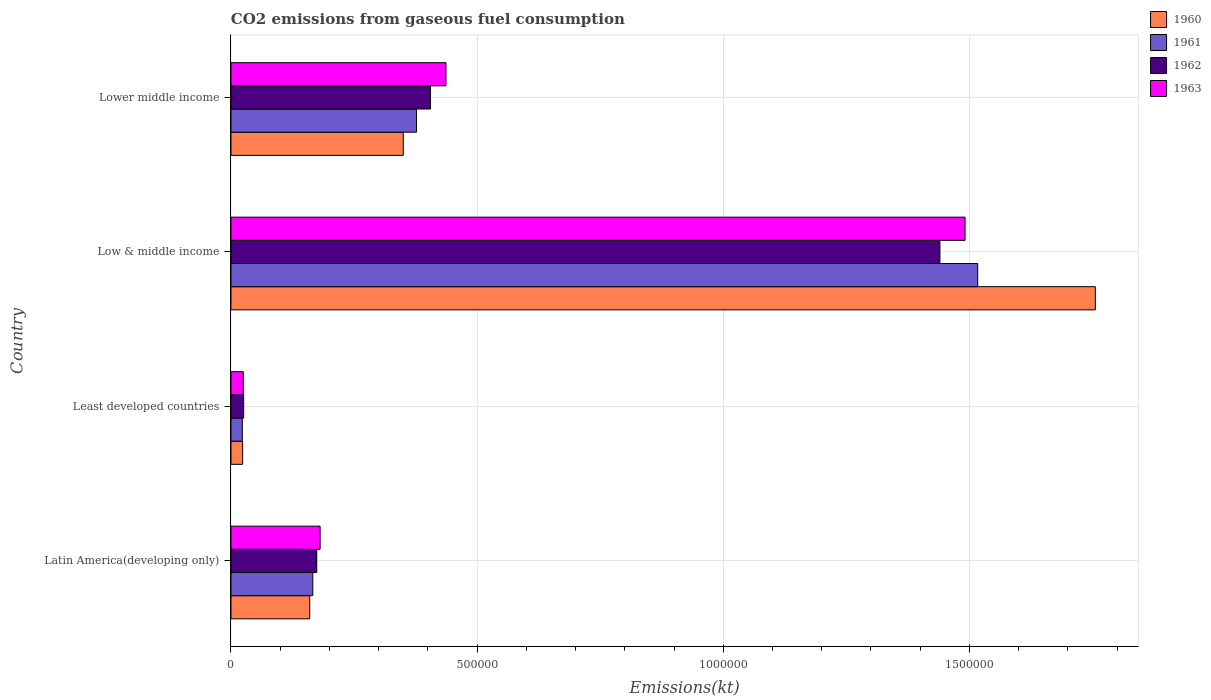Are the number of bars per tick equal to the number of legend labels?
Your answer should be very brief. Yes. How many bars are there on the 3rd tick from the bottom?
Make the answer very short. 4. What is the label of the 3rd group of bars from the top?
Ensure brevity in your answer.  Least developed countries. What is the amount of CO2 emitted in 1963 in Low & middle income?
Your answer should be compact. 1.49e+06. Across all countries, what is the maximum amount of CO2 emitted in 1963?
Ensure brevity in your answer.  1.49e+06. Across all countries, what is the minimum amount of CO2 emitted in 1961?
Your answer should be compact. 2.31e+04. In which country was the amount of CO2 emitted in 1961 minimum?
Your answer should be very brief. Least developed countries. What is the total amount of CO2 emitted in 1961 in the graph?
Your response must be concise. 2.08e+06. What is the difference between the amount of CO2 emitted in 1960 in Latin America(developing only) and that in Lower middle income?
Give a very brief answer. -1.90e+05. What is the difference between the amount of CO2 emitted in 1963 in Latin America(developing only) and the amount of CO2 emitted in 1960 in Lower middle income?
Keep it short and to the point. -1.69e+05. What is the average amount of CO2 emitted in 1960 per country?
Provide a succinct answer. 5.72e+05. What is the difference between the amount of CO2 emitted in 1962 and amount of CO2 emitted in 1961 in Low & middle income?
Ensure brevity in your answer.  -7.68e+04. In how many countries, is the amount of CO2 emitted in 1963 greater than 1700000 kt?
Provide a short and direct response. 0. What is the ratio of the amount of CO2 emitted in 1961 in Least developed countries to that in Low & middle income?
Keep it short and to the point. 0.02. What is the difference between the highest and the second highest amount of CO2 emitted in 1961?
Provide a succinct answer. 1.14e+06. What is the difference between the highest and the lowest amount of CO2 emitted in 1962?
Keep it short and to the point. 1.41e+06. In how many countries, is the amount of CO2 emitted in 1960 greater than the average amount of CO2 emitted in 1960 taken over all countries?
Make the answer very short. 1. Is it the case that in every country, the sum of the amount of CO2 emitted in 1963 and amount of CO2 emitted in 1961 is greater than the amount of CO2 emitted in 1962?
Ensure brevity in your answer.  Yes. How many countries are there in the graph?
Ensure brevity in your answer.  4. What is the difference between two consecutive major ticks on the X-axis?
Provide a short and direct response. 5.00e+05. Does the graph contain any zero values?
Your answer should be compact. No. Does the graph contain grids?
Your answer should be very brief. Yes. Where does the legend appear in the graph?
Ensure brevity in your answer.  Top right. How are the legend labels stacked?
Offer a very short reply. Vertical. What is the title of the graph?
Provide a short and direct response. CO2 emissions from gaseous fuel consumption. Does "2004" appear as one of the legend labels in the graph?
Keep it short and to the point. No. What is the label or title of the X-axis?
Provide a succinct answer. Emissions(kt). What is the Emissions(kt) of 1960 in Latin America(developing only)?
Keep it short and to the point. 1.60e+05. What is the Emissions(kt) in 1961 in Latin America(developing only)?
Provide a short and direct response. 1.66e+05. What is the Emissions(kt) of 1962 in Latin America(developing only)?
Provide a succinct answer. 1.74e+05. What is the Emissions(kt) of 1963 in Latin America(developing only)?
Make the answer very short. 1.81e+05. What is the Emissions(kt) in 1960 in Least developed countries?
Provide a succinct answer. 2.37e+04. What is the Emissions(kt) of 1961 in Least developed countries?
Provide a short and direct response. 2.31e+04. What is the Emissions(kt) in 1962 in Least developed countries?
Your answer should be compact. 2.58e+04. What is the Emissions(kt) of 1963 in Least developed countries?
Offer a terse response. 2.49e+04. What is the Emissions(kt) of 1960 in Low & middle income?
Ensure brevity in your answer.  1.76e+06. What is the Emissions(kt) in 1961 in Low & middle income?
Your response must be concise. 1.52e+06. What is the Emissions(kt) in 1962 in Low & middle income?
Make the answer very short. 1.44e+06. What is the Emissions(kt) of 1963 in Low & middle income?
Your answer should be compact. 1.49e+06. What is the Emissions(kt) of 1960 in Lower middle income?
Your answer should be compact. 3.50e+05. What is the Emissions(kt) of 1961 in Lower middle income?
Ensure brevity in your answer.  3.77e+05. What is the Emissions(kt) of 1962 in Lower middle income?
Give a very brief answer. 4.05e+05. What is the Emissions(kt) of 1963 in Lower middle income?
Ensure brevity in your answer.  4.37e+05. Across all countries, what is the maximum Emissions(kt) of 1960?
Keep it short and to the point. 1.76e+06. Across all countries, what is the maximum Emissions(kt) of 1961?
Your answer should be compact. 1.52e+06. Across all countries, what is the maximum Emissions(kt) in 1962?
Offer a very short reply. 1.44e+06. Across all countries, what is the maximum Emissions(kt) of 1963?
Your answer should be compact. 1.49e+06. Across all countries, what is the minimum Emissions(kt) of 1960?
Provide a short and direct response. 2.37e+04. Across all countries, what is the minimum Emissions(kt) in 1961?
Provide a short and direct response. 2.31e+04. Across all countries, what is the minimum Emissions(kt) in 1962?
Provide a short and direct response. 2.58e+04. Across all countries, what is the minimum Emissions(kt) in 1963?
Ensure brevity in your answer.  2.49e+04. What is the total Emissions(kt) in 1960 in the graph?
Your answer should be very brief. 2.29e+06. What is the total Emissions(kt) in 1961 in the graph?
Your answer should be compact. 2.08e+06. What is the total Emissions(kt) in 1962 in the graph?
Keep it short and to the point. 2.05e+06. What is the total Emissions(kt) in 1963 in the graph?
Provide a short and direct response. 2.13e+06. What is the difference between the Emissions(kt) in 1960 in Latin America(developing only) and that in Least developed countries?
Provide a short and direct response. 1.36e+05. What is the difference between the Emissions(kt) in 1961 in Latin America(developing only) and that in Least developed countries?
Offer a very short reply. 1.43e+05. What is the difference between the Emissions(kt) of 1962 in Latin America(developing only) and that in Least developed countries?
Keep it short and to the point. 1.48e+05. What is the difference between the Emissions(kt) of 1963 in Latin America(developing only) and that in Least developed countries?
Your answer should be very brief. 1.56e+05. What is the difference between the Emissions(kt) in 1960 in Latin America(developing only) and that in Low & middle income?
Your answer should be compact. -1.60e+06. What is the difference between the Emissions(kt) in 1961 in Latin America(developing only) and that in Low & middle income?
Ensure brevity in your answer.  -1.35e+06. What is the difference between the Emissions(kt) of 1962 in Latin America(developing only) and that in Low & middle income?
Your answer should be very brief. -1.27e+06. What is the difference between the Emissions(kt) of 1963 in Latin America(developing only) and that in Low & middle income?
Your answer should be very brief. -1.31e+06. What is the difference between the Emissions(kt) of 1960 in Latin America(developing only) and that in Lower middle income?
Ensure brevity in your answer.  -1.90e+05. What is the difference between the Emissions(kt) of 1961 in Latin America(developing only) and that in Lower middle income?
Make the answer very short. -2.11e+05. What is the difference between the Emissions(kt) in 1962 in Latin America(developing only) and that in Lower middle income?
Your response must be concise. -2.31e+05. What is the difference between the Emissions(kt) in 1963 in Latin America(developing only) and that in Lower middle income?
Offer a terse response. -2.56e+05. What is the difference between the Emissions(kt) in 1960 in Least developed countries and that in Low & middle income?
Your answer should be very brief. -1.73e+06. What is the difference between the Emissions(kt) in 1961 in Least developed countries and that in Low & middle income?
Give a very brief answer. -1.49e+06. What is the difference between the Emissions(kt) of 1962 in Least developed countries and that in Low & middle income?
Offer a very short reply. -1.41e+06. What is the difference between the Emissions(kt) of 1963 in Least developed countries and that in Low & middle income?
Your response must be concise. -1.47e+06. What is the difference between the Emissions(kt) of 1960 in Least developed countries and that in Lower middle income?
Provide a succinct answer. -3.26e+05. What is the difference between the Emissions(kt) of 1961 in Least developed countries and that in Lower middle income?
Make the answer very short. -3.54e+05. What is the difference between the Emissions(kt) of 1962 in Least developed countries and that in Lower middle income?
Your answer should be very brief. -3.80e+05. What is the difference between the Emissions(kt) of 1963 in Least developed countries and that in Lower middle income?
Ensure brevity in your answer.  -4.12e+05. What is the difference between the Emissions(kt) in 1960 in Low & middle income and that in Lower middle income?
Your response must be concise. 1.41e+06. What is the difference between the Emissions(kt) in 1961 in Low & middle income and that in Lower middle income?
Ensure brevity in your answer.  1.14e+06. What is the difference between the Emissions(kt) of 1962 in Low & middle income and that in Lower middle income?
Your answer should be compact. 1.03e+06. What is the difference between the Emissions(kt) in 1963 in Low & middle income and that in Lower middle income?
Provide a succinct answer. 1.05e+06. What is the difference between the Emissions(kt) in 1960 in Latin America(developing only) and the Emissions(kt) in 1961 in Least developed countries?
Make the answer very short. 1.37e+05. What is the difference between the Emissions(kt) of 1960 in Latin America(developing only) and the Emissions(kt) of 1962 in Least developed countries?
Keep it short and to the point. 1.34e+05. What is the difference between the Emissions(kt) of 1960 in Latin America(developing only) and the Emissions(kt) of 1963 in Least developed countries?
Make the answer very short. 1.35e+05. What is the difference between the Emissions(kt) of 1961 in Latin America(developing only) and the Emissions(kt) of 1962 in Least developed countries?
Offer a terse response. 1.40e+05. What is the difference between the Emissions(kt) of 1961 in Latin America(developing only) and the Emissions(kt) of 1963 in Least developed countries?
Offer a terse response. 1.41e+05. What is the difference between the Emissions(kt) of 1962 in Latin America(developing only) and the Emissions(kt) of 1963 in Least developed countries?
Your response must be concise. 1.49e+05. What is the difference between the Emissions(kt) in 1960 in Latin America(developing only) and the Emissions(kt) in 1961 in Low & middle income?
Make the answer very short. -1.36e+06. What is the difference between the Emissions(kt) of 1960 in Latin America(developing only) and the Emissions(kt) of 1962 in Low & middle income?
Your answer should be compact. -1.28e+06. What is the difference between the Emissions(kt) in 1960 in Latin America(developing only) and the Emissions(kt) in 1963 in Low & middle income?
Your answer should be very brief. -1.33e+06. What is the difference between the Emissions(kt) of 1961 in Latin America(developing only) and the Emissions(kt) of 1962 in Low & middle income?
Give a very brief answer. -1.27e+06. What is the difference between the Emissions(kt) in 1961 in Latin America(developing only) and the Emissions(kt) in 1963 in Low & middle income?
Your answer should be compact. -1.33e+06. What is the difference between the Emissions(kt) in 1962 in Latin America(developing only) and the Emissions(kt) in 1963 in Low & middle income?
Offer a terse response. -1.32e+06. What is the difference between the Emissions(kt) of 1960 in Latin America(developing only) and the Emissions(kt) of 1961 in Lower middle income?
Provide a short and direct response. -2.17e+05. What is the difference between the Emissions(kt) in 1960 in Latin America(developing only) and the Emissions(kt) in 1962 in Lower middle income?
Ensure brevity in your answer.  -2.45e+05. What is the difference between the Emissions(kt) in 1960 in Latin America(developing only) and the Emissions(kt) in 1963 in Lower middle income?
Ensure brevity in your answer.  -2.77e+05. What is the difference between the Emissions(kt) of 1961 in Latin America(developing only) and the Emissions(kt) of 1962 in Lower middle income?
Ensure brevity in your answer.  -2.39e+05. What is the difference between the Emissions(kt) in 1961 in Latin America(developing only) and the Emissions(kt) in 1963 in Lower middle income?
Offer a terse response. -2.71e+05. What is the difference between the Emissions(kt) of 1962 in Latin America(developing only) and the Emissions(kt) of 1963 in Lower middle income?
Provide a short and direct response. -2.63e+05. What is the difference between the Emissions(kt) of 1960 in Least developed countries and the Emissions(kt) of 1961 in Low & middle income?
Provide a succinct answer. -1.49e+06. What is the difference between the Emissions(kt) of 1960 in Least developed countries and the Emissions(kt) of 1962 in Low & middle income?
Offer a terse response. -1.42e+06. What is the difference between the Emissions(kt) in 1960 in Least developed countries and the Emissions(kt) in 1963 in Low & middle income?
Offer a very short reply. -1.47e+06. What is the difference between the Emissions(kt) of 1961 in Least developed countries and the Emissions(kt) of 1962 in Low & middle income?
Provide a succinct answer. -1.42e+06. What is the difference between the Emissions(kt) of 1961 in Least developed countries and the Emissions(kt) of 1963 in Low & middle income?
Provide a succinct answer. -1.47e+06. What is the difference between the Emissions(kt) in 1962 in Least developed countries and the Emissions(kt) in 1963 in Low & middle income?
Your answer should be compact. -1.47e+06. What is the difference between the Emissions(kt) of 1960 in Least developed countries and the Emissions(kt) of 1961 in Lower middle income?
Provide a short and direct response. -3.53e+05. What is the difference between the Emissions(kt) in 1960 in Least developed countries and the Emissions(kt) in 1962 in Lower middle income?
Provide a short and direct response. -3.82e+05. What is the difference between the Emissions(kt) of 1960 in Least developed countries and the Emissions(kt) of 1963 in Lower middle income?
Provide a succinct answer. -4.13e+05. What is the difference between the Emissions(kt) in 1961 in Least developed countries and the Emissions(kt) in 1962 in Lower middle income?
Give a very brief answer. -3.82e+05. What is the difference between the Emissions(kt) in 1961 in Least developed countries and the Emissions(kt) in 1963 in Lower middle income?
Ensure brevity in your answer.  -4.14e+05. What is the difference between the Emissions(kt) of 1962 in Least developed countries and the Emissions(kt) of 1963 in Lower middle income?
Provide a short and direct response. -4.11e+05. What is the difference between the Emissions(kt) of 1960 in Low & middle income and the Emissions(kt) of 1961 in Lower middle income?
Make the answer very short. 1.38e+06. What is the difference between the Emissions(kt) in 1960 in Low & middle income and the Emissions(kt) in 1962 in Lower middle income?
Give a very brief answer. 1.35e+06. What is the difference between the Emissions(kt) in 1960 in Low & middle income and the Emissions(kt) in 1963 in Lower middle income?
Offer a terse response. 1.32e+06. What is the difference between the Emissions(kt) in 1961 in Low & middle income and the Emissions(kt) in 1962 in Lower middle income?
Your answer should be very brief. 1.11e+06. What is the difference between the Emissions(kt) in 1961 in Low & middle income and the Emissions(kt) in 1963 in Lower middle income?
Give a very brief answer. 1.08e+06. What is the difference between the Emissions(kt) of 1962 in Low & middle income and the Emissions(kt) of 1963 in Lower middle income?
Offer a very short reply. 1.00e+06. What is the average Emissions(kt) in 1960 per country?
Your answer should be very brief. 5.72e+05. What is the average Emissions(kt) in 1961 per country?
Give a very brief answer. 5.21e+05. What is the average Emissions(kt) in 1962 per country?
Give a very brief answer. 5.11e+05. What is the average Emissions(kt) of 1963 per country?
Keep it short and to the point. 5.34e+05. What is the difference between the Emissions(kt) in 1960 and Emissions(kt) in 1961 in Latin America(developing only)?
Provide a succinct answer. -6230.23. What is the difference between the Emissions(kt) of 1960 and Emissions(kt) of 1962 in Latin America(developing only)?
Keep it short and to the point. -1.43e+04. What is the difference between the Emissions(kt) of 1960 and Emissions(kt) of 1963 in Latin America(developing only)?
Your answer should be compact. -2.11e+04. What is the difference between the Emissions(kt) in 1961 and Emissions(kt) in 1962 in Latin America(developing only)?
Your response must be concise. -8049.06. What is the difference between the Emissions(kt) in 1961 and Emissions(kt) in 1963 in Latin America(developing only)?
Offer a terse response. -1.49e+04. What is the difference between the Emissions(kt) of 1962 and Emissions(kt) of 1963 in Latin America(developing only)?
Give a very brief answer. -6838.95. What is the difference between the Emissions(kt) in 1960 and Emissions(kt) in 1961 in Least developed countries?
Provide a succinct answer. 649.13. What is the difference between the Emissions(kt) in 1960 and Emissions(kt) in 1962 in Least developed countries?
Offer a very short reply. -2100.39. What is the difference between the Emissions(kt) in 1960 and Emissions(kt) in 1963 in Least developed countries?
Provide a succinct answer. -1221.77. What is the difference between the Emissions(kt) of 1961 and Emissions(kt) of 1962 in Least developed countries?
Provide a short and direct response. -2749.52. What is the difference between the Emissions(kt) of 1961 and Emissions(kt) of 1963 in Least developed countries?
Your response must be concise. -1870.9. What is the difference between the Emissions(kt) of 1962 and Emissions(kt) of 1963 in Least developed countries?
Your answer should be very brief. 878.62. What is the difference between the Emissions(kt) in 1960 and Emissions(kt) in 1961 in Low & middle income?
Your response must be concise. 2.39e+05. What is the difference between the Emissions(kt) of 1960 and Emissions(kt) of 1962 in Low & middle income?
Ensure brevity in your answer.  3.16e+05. What is the difference between the Emissions(kt) in 1960 and Emissions(kt) in 1963 in Low & middle income?
Provide a succinct answer. 2.65e+05. What is the difference between the Emissions(kt) in 1961 and Emissions(kt) in 1962 in Low & middle income?
Make the answer very short. 7.68e+04. What is the difference between the Emissions(kt) in 1961 and Emissions(kt) in 1963 in Low & middle income?
Offer a very short reply. 2.57e+04. What is the difference between the Emissions(kt) of 1962 and Emissions(kt) of 1963 in Low & middle income?
Provide a short and direct response. -5.11e+04. What is the difference between the Emissions(kt) of 1960 and Emissions(kt) of 1961 in Lower middle income?
Offer a very short reply. -2.70e+04. What is the difference between the Emissions(kt) of 1960 and Emissions(kt) of 1962 in Lower middle income?
Keep it short and to the point. -5.54e+04. What is the difference between the Emissions(kt) in 1960 and Emissions(kt) in 1963 in Lower middle income?
Your answer should be compact. -8.68e+04. What is the difference between the Emissions(kt) in 1961 and Emissions(kt) in 1962 in Lower middle income?
Provide a short and direct response. -2.84e+04. What is the difference between the Emissions(kt) of 1961 and Emissions(kt) of 1963 in Lower middle income?
Offer a terse response. -5.98e+04. What is the difference between the Emissions(kt) in 1962 and Emissions(kt) in 1963 in Lower middle income?
Provide a succinct answer. -3.14e+04. What is the ratio of the Emissions(kt) in 1960 in Latin America(developing only) to that in Least developed countries?
Give a very brief answer. 6.75. What is the ratio of the Emissions(kt) in 1961 in Latin America(developing only) to that in Least developed countries?
Keep it short and to the point. 7.21. What is the ratio of the Emissions(kt) in 1962 in Latin America(developing only) to that in Least developed countries?
Your answer should be very brief. 6.75. What is the ratio of the Emissions(kt) in 1963 in Latin America(developing only) to that in Least developed countries?
Provide a succinct answer. 7.27. What is the ratio of the Emissions(kt) in 1960 in Latin America(developing only) to that in Low & middle income?
Provide a succinct answer. 0.09. What is the ratio of the Emissions(kt) in 1961 in Latin America(developing only) to that in Low & middle income?
Keep it short and to the point. 0.11. What is the ratio of the Emissions(kt) in 1962 in Latin America(developing only) to that in Low & middle income?
Give a very brief answer. 0.12. What is the ratio of the Emissions(kt) in 1963 in Latin America(developing only) to that in Low & middle income?
Offer a terse response. 0.12. What is the ratio of the Emissions(kt) in 1960 in Latin America(developing only) to that in Lower middle income?
Your answer should be compact. 0.46. What is the ratio of the Emissions(kt) in 1961 in Latin America(developing only) to that in Lower middle income?
Your response must be concise. 0.44. What is the ratio of the Emissions(kt) of 1962 in Latin America(developing only) to that in Lower middle income?
Keep it short and to the point. 0.43. What is the ratio of the Emissions(kt) in 1963 in Latin America(developing only) to that in Lower middle income?
Offer a terse response. 0.41. What is the ratio of the Emissions(kt) of 1960 in Least developed countries to that in Low & middle income?
Offer a terse response. 0.01. What is the ratio of the Emissions(kt) in 1961 in Least developed countries to that in Low & middle income?
Your answer should be compact. 0.02. What is the ratio of the Emissions(kt) of 1962 in Least developed countries to that in Low & middle income?
Make the answer very short. 0.02. What is the ratio of the Emissions(kt) of 1963 in Least developed countries to that in Low & middle income?
Offer a very short reply. 0.02. What is the ratio of the Emissions(kt) in 1960 in Least developed countries to that in Lower middle income?
Offer a terse response. 0.07. What is the ratio of the Emissions(kt) of 1961 in Least developed countries to that in Lower middle income?
Your answer should be very brief. 0.06. What is the ratio of the Emissions(kt) of 1962 in Least developed countries to that in Lower middle income?
Give a very brief answer. 0.06. What is the ratio of the Emissions(kt) in 1963 in Least developed countries to that in Lower middle income?
Make the answer very short. 0.06. What is the ratio of the Emissions(kt) in 1960 in Low & middle income to that in Lower middle income?
Give a very brief answer. 5.02. What is the ratio of the Emissions(kt) in 1961 in Low & middle income to that in Lower middle income?
Your answer should be very brief. 4.02. What is the ratio of the Emissions(kt) in 1962 in Low & middle income to that in Lower middle income?
Offer a very short reply. 3.55. What is the ratio of the Emissions(kt) of 1963 in Low & middle income to that in Lower middle income?
Your response must be concise. 3.41. What is the difference between the highest and the second highest Emissions(kt) in 1960?
Your answer should be compact. 1.41e+06. What is the difference between the highest and the second highest Emissions(kt) of 1961?
Offer a terse response. 1.14e+06. What is the difference between the highest and the second highest Emissions(kt) of 1962?
Provide a short and direct response. 1.03e+06. What is the difference between the highest and the second highest Emissions(kt) in 1963?
Provide a succinct answer. 1.05e+06. What is the difference between the highest and the lowest Emissions(kt) in 1960?
Offer a very short reply. 1.73e+06. What is the difference between the highest and the lowest Emissions(kt) in 1961?
Provide a short and direct response. 1.49e+06. What is the difference between the highest and the lowest Emissions(kt) of 1962?
Make the answer very short. 1.41e+06. What is the difference between the highest and the lowest Emissions(kt) of 1963?
Keep it short and to the point. 1.47e+06. 